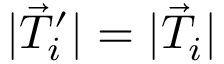<formula> <loc_0><loc_0><loc_500><loc_500>| \vec { T } _ { i } ^ { \prime } | = | \vec { T } _ { i } |</formula> 